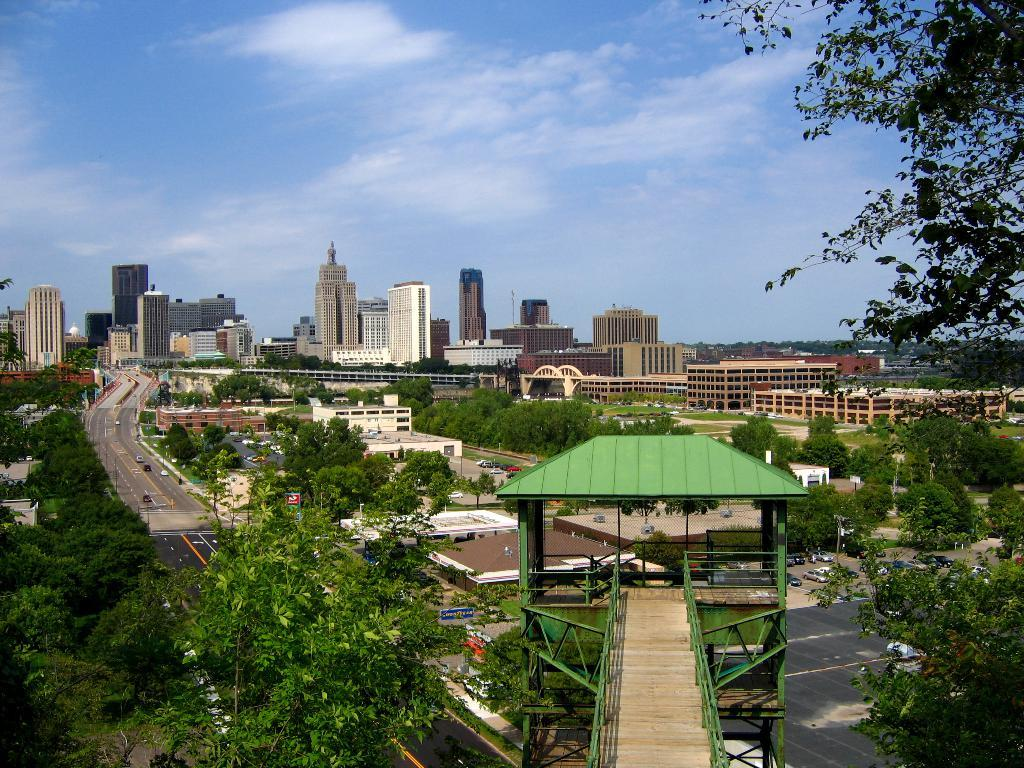What type of structure can be seen in the image? There is a bridge in the image. What type of vegetation is present in the image? There are trees in the image. What else can be seen moving in the image? Vehicles are present in the image. What type of man-made structures are visible in the image? There are buildings in the image. What is visible at the top of the image? The sky is visible at the top of the image. What can be seen in the sky? Clouds are present in the sky. What type of meat is being protested against in the image? There is no protest or meat present in the image. What type of iron is used to construct the bridge in the image? The image does not provide information about the materials used to construct the bridge. 